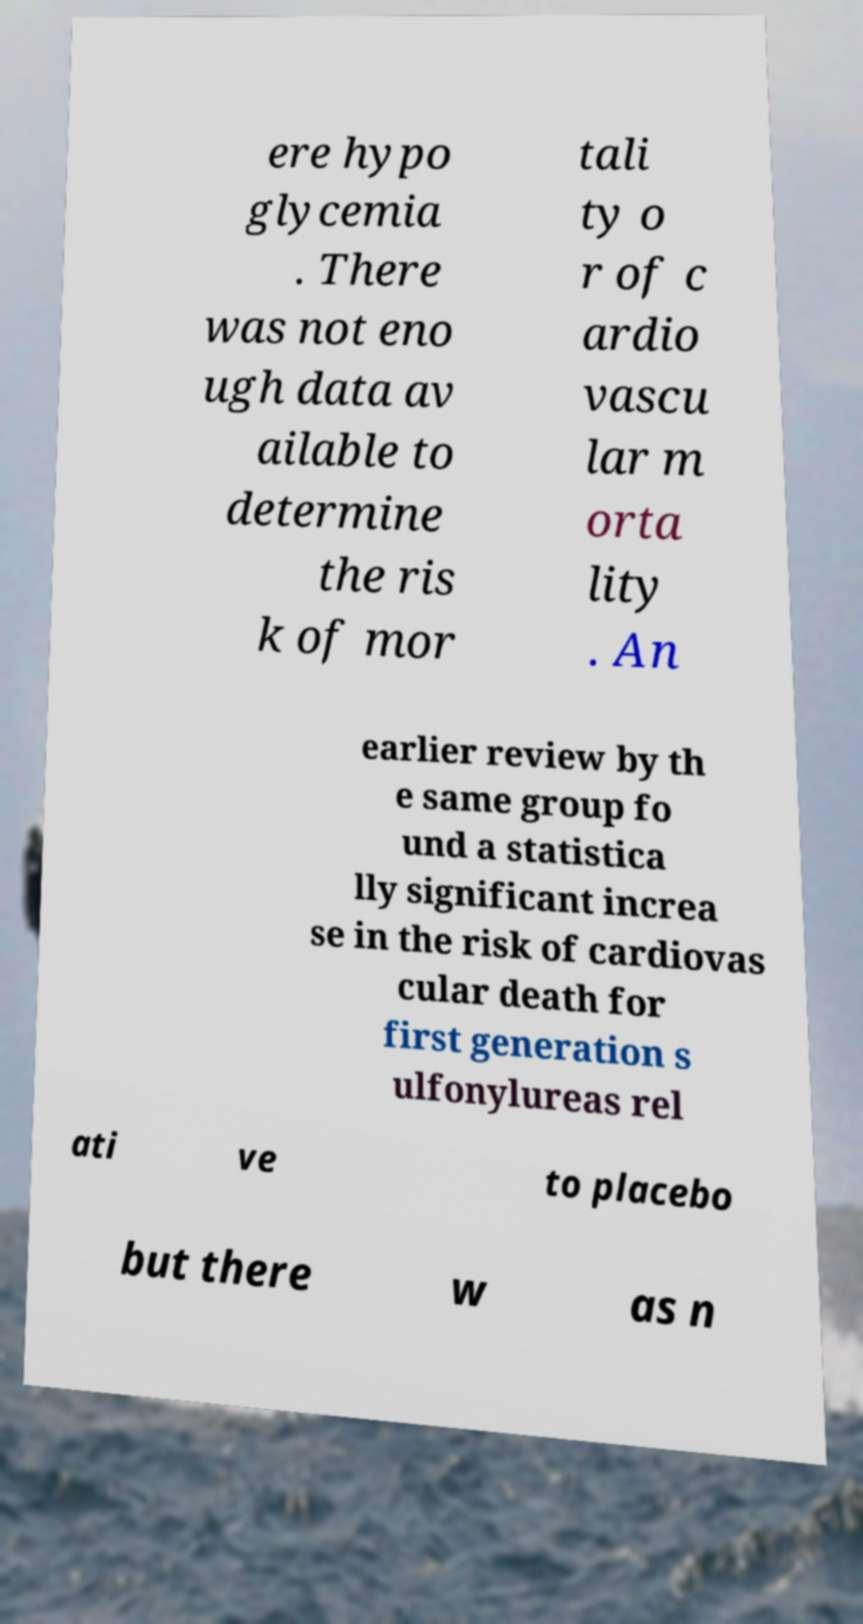For documentation purposes, I need the text within this image transcribed. Could you provide that? ere hypo glycemia . There was not eno ugh data av ailable to determine the ris k of mor tali ty o r of c ardio vascu lar m orta lity . An earlier review by th e same group fo und a statistica lly significant increa se in the risk of cardiovas cular death for first generation s ulfonylureas rel ati ve to placebo but there w as n 